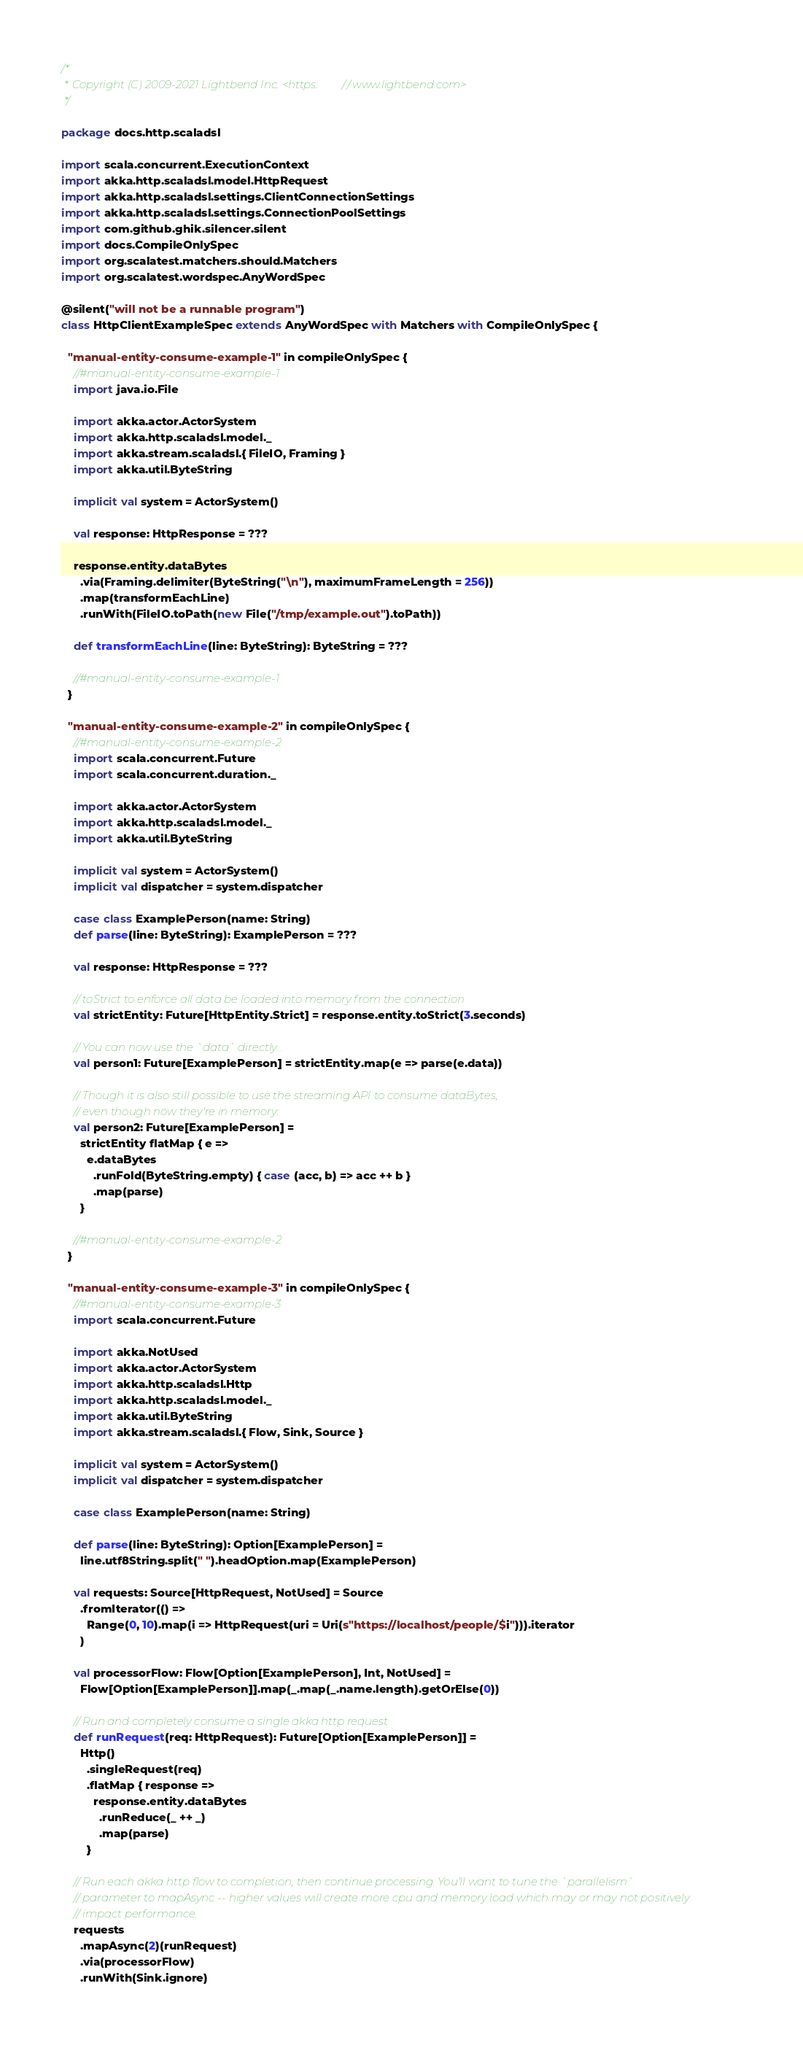<code> <loc_0><loc_0><loc_500><loc_500><_Scala_>/*
 * Copyright (C) 2009-2021 Lightbend Inc. <https://www.lightbend.com>
 */

package docs.http.scaladsl

import scala.concurrent.ExecutionContext
import akka.http.scaladsl.model.HttpRequest
import akka.http.scaladsl.settings.ClientConnectionSettings
import akka.http.scaladsl.settings.ConnectionPoolSettings
import com.github.ghik.silencer.silent
import docs.CompileOnlySpec
import org.scalatest.matchers.should.Matchers
import org.scalatest.wordspec.AnyWordSpec

@silent("will not be a runnable program")
class HttpClientExampleSpec extends AnyWordSpec with Matchers with CompileOnlySpec {

  "manual-entity-consume-example-1" in compileOnlySpec {
    //#manual-entity-consume-example-1
    import java.io.File

    import akka.actor.ActorSystem
    import akka.http.scaladsl.model._
    import akka.stream.scaladsl.{ FileIO, Framing }
    import akka.util.ByteString

    implicit val system = ActorSystem()

    val response: HttpResponse = ???

    response.entity.dataBytes
      .via(Framing.delimiter(ByteString("\n"), maximumFrameLength = 256))
      .map(transformEachLine)
      .runWith(FileIO.toPath(new File("/tmp/example.out").toPath))

    def transformEachLine(line: ByteString): ByteString = ???

    //#manual-entity-consume-example-1
  }

  "manual-entity-consume-example-2" in compileOnlySpec {
    //#manual-entity-consume-example-2
    import scala.concurrent.Future
    import scala.concurrent.duration._

    import akka.actor.ActorSystem
    import akka.http.scaladsl.model._
    import akka.util.ByteString

    implicit val system = ActorSystem()
    implicit val dispatcher = system.dispatcher

    case class ExamplePerson(name: String)
    def parse(line: ByteString): ExamplePerson = ???

    val response: HttpResponse = ???

    // toStrict to enforce all data be loaded into memory from the connection
    val strictEntity: Future[HttpEntity.Strict] = response.entity.toStrict(3.seconds)

    // You can now use the `data` directly...
    val person1: Future[ExamplePerson] = strictEntity.map(e => parse(e.data))

    // Though it is also still possible to use the streaming API to consume dataBytes,
    // even though now they're in memory:
    val person2: Future[ExamplePerson] =
      strictEntity flatMap { e =>
        e.dataBytes
          .runFold(ByteString.empty) { case (acc, b) => acc ++ b }
          .map(parse)
      }

    //#manual-entity-consume-example-2
  }

  "manual-entity-consume-example-3" in compileOnlySpec {
    //#manual-entity-consume-example-3
    import scala.concurrent.Future

    import akka.NotUsed
    import akka.actor.ActorSystem
    import akka.http.scaladsl.Http
    import akka.http.scaladsl.model._
    import akka.util.ByteString
    import akka.stream.scaladsl.{ Flow, Sink, Source }

    implicit val system = ActorSystem()
    implicit val dispatcher = system.dispatcher

    case class ExamplePerson(name: String)

    def parse(line: ByteString): Option[ExamplePerson] =
      line.utf8String.split(" ").headOption.map(ExamplePerson)

    val requests: Source[HttpRequest, NotUsed] = Source
      .fromIterator(() =>
        Range(0, 10).map(i => HttpRequest(uri = Uri(s"https://localhost/people/$i"))).iterator
      )

    val processorFlow: Flow[Option[ExamplePerson], Int, NotUsed] =
      Flow[Option[ExamplePerson]].map(_.map(_.name.length).getOrElse(0))

    // Run and completely consume a single akka http request
    def runRequest(req: HttpRequest): Future[Option[ExamplePerson]] =
      Http()
        .singleRequest(req)
        .flatMap { response =>
          response.entity.dataBytes
            .runReduce(_ ++ _)
            .map(parse)
        }

    // Run each akka http flow to completion, then continue processing. You'll want to tune the `parallelism`
    // parameter to mapAsync -- higher values will create more cpu and memory load which may or may not positively
    // impact performance.
    requests
      .mapAsync(2)(runRequest)
      .via(processorFlow)
      .runWith(Sink.ignore)
</code> 